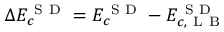<formula> <loc_0><loc_0><loc_500><loc_500>\Delta E _ { c } ^ { S D } = E _ { c } ^ { S D } - E _ { c , L B } ^ { S D }</formula> 